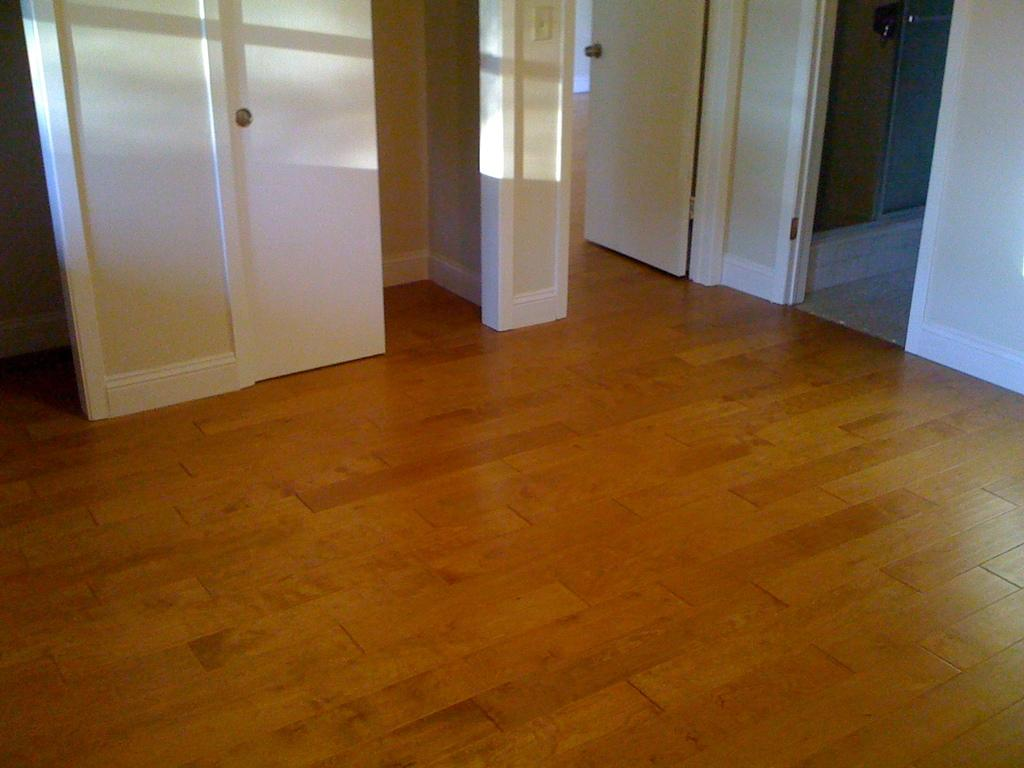What color is present in the image? The image contains a white color. What type of structure can be seen in the image? There is a wall in the image. What type of flooring is visible in the image? There is a wooden floor in the image. What type of pump is being used for the war in the image? There is no pump or war present in the image; it only contains a wall and a wooden floor. 